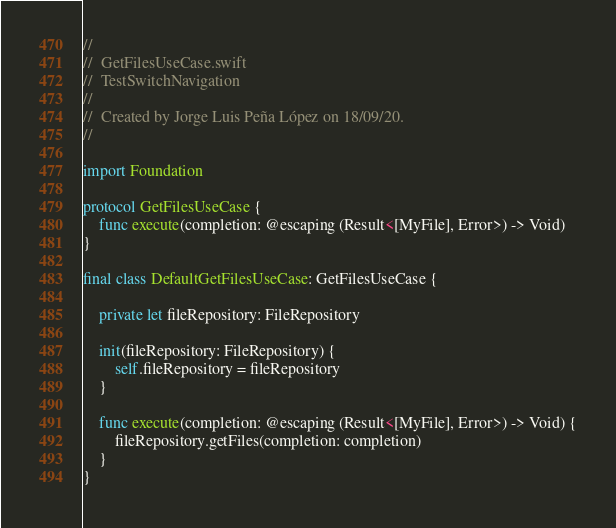Convert code to text. <code><loc_0><loc_0><loc_500><loc_500><_Swift_>//
//  GetFilesUseCase.swift
//  TestSwitchNavigation
//
//  Created by Jorge Luis Peña López on 18/09/20.
//

import Foundation

protocol GetFilesUseCase {
    func execute(completion: @escaping (Result<[MyFile], Error>) -> Void)
}

final class DefaultGetFilesUseCase: GetFilesUseCase {
    
    private let fileRepository: FileRepository
    
    init(fileRepository: FileRepository) {
        self.fileRepository = fileRepository
    }
    
    func execute(completion: @escaping (Result<[MyFile], Error>) -> Void) {
        fileRepository.getFiles(completion: completion)        
    }    
}
</code> 